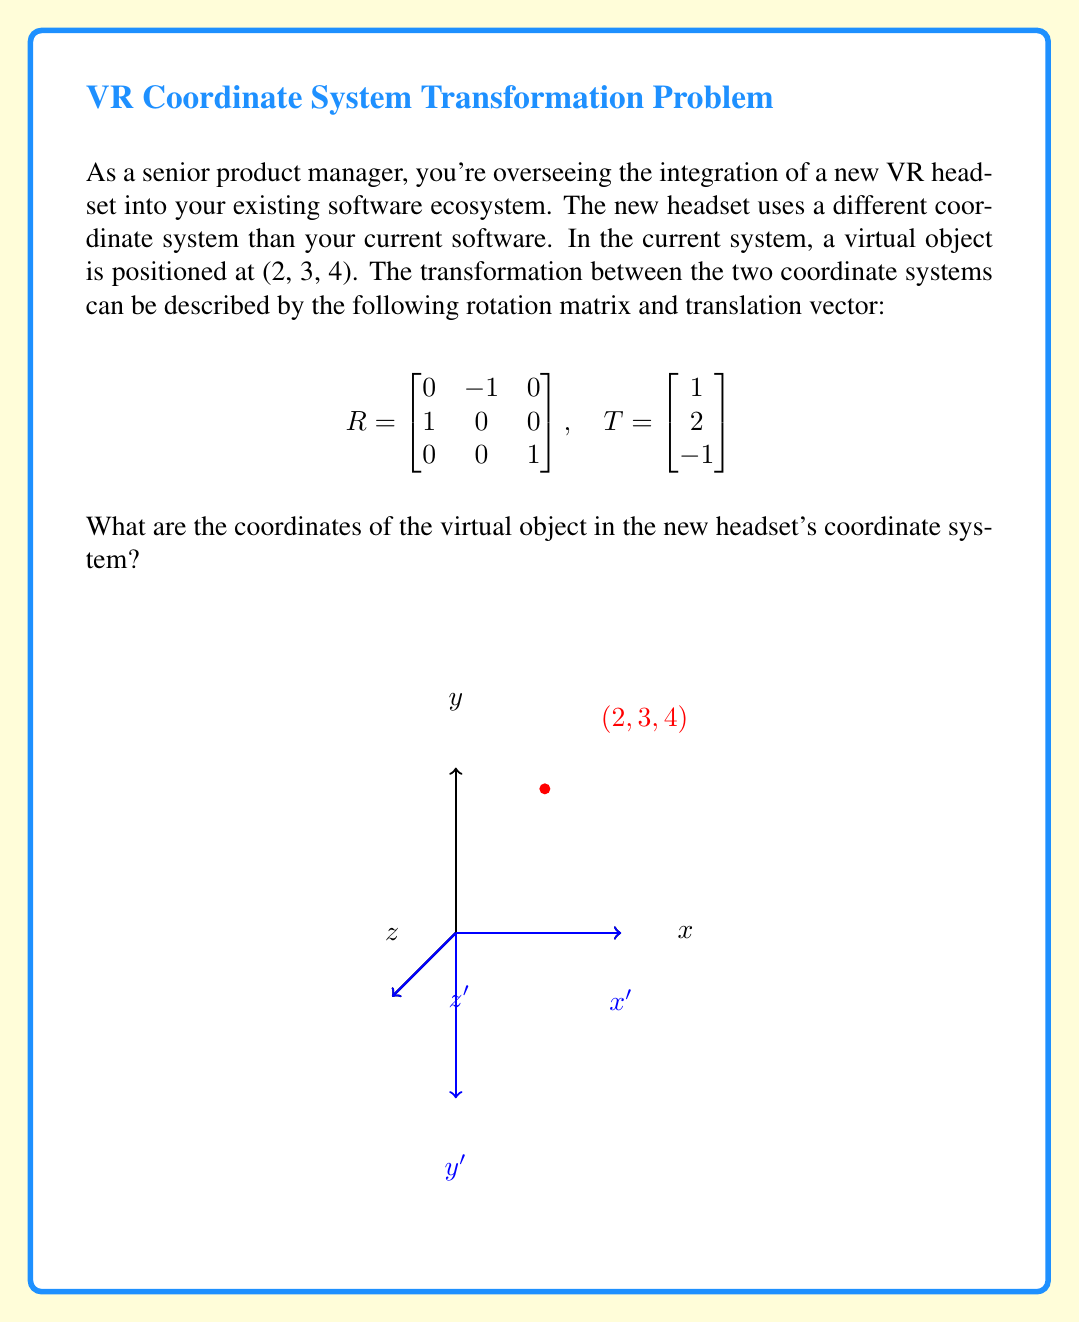Could you help me with this problem? To convert the coordinates from one system to another, we need to apply the rotation and translation transformations. Let's break this down step-by-step:

1) First, we apply the rotation. The rotation is applied by multiplying the rotation matrix $R$ with the original position vector:

   $$R \cdot \begin{bmatrix} 2 \\ 3 \\ 4 \end{bmatrix} = 
   \begin{bmatrix}
   0 & -1 & 0 \\
   1 & 0 & 0 \\
   0 & 0 & 1
   \end{bmatrix} \cdot 
   \begin{bmatrix} 2 \\ 3 \\ 4 \end{bmatrix}$$

2) Let's perform this matrix multiplication:
   
   $$\begin{bmatrix}
   (0 \cdot 2) + (-1 \cdot 3) + (0 \cdot 4) \\
   (1 \cdot 2) + (0 \cdot 3) + (0 \cdot 4) \\
   (0 \cdot 2) + (0 \cdot 3) + (1 \cdot 4)
   \end{bmatrix} = 
   \begin{bmatrix} -3 \\ 2 \\ 4 \end{bmatrix}$$

3) Now that we've applied the rotation, we need to apply the translation. This is done by adding the translation vector $T$ to our rotated coordinates:

   $$\begin{bmatrix} -3 \\ 2 \\ 4 \end{bmatrix} + 
   \begin{bmatrix} 1 \\ 2 \\ -1 \end{bmatrix} = 
   \begin{bmatrix} -3 + 1 \\ 2 + 2 \\ 4 - 1 \end{bmatrix} = 
   \begin{bmatrix} -2 \\ 4 \\ 3 \end{bmatrix}$$

Therefore, the coordinates of the virtual object in the new headset's coordinate system are (-2, 4, 3).
Answer: (-2, 4, 3) 